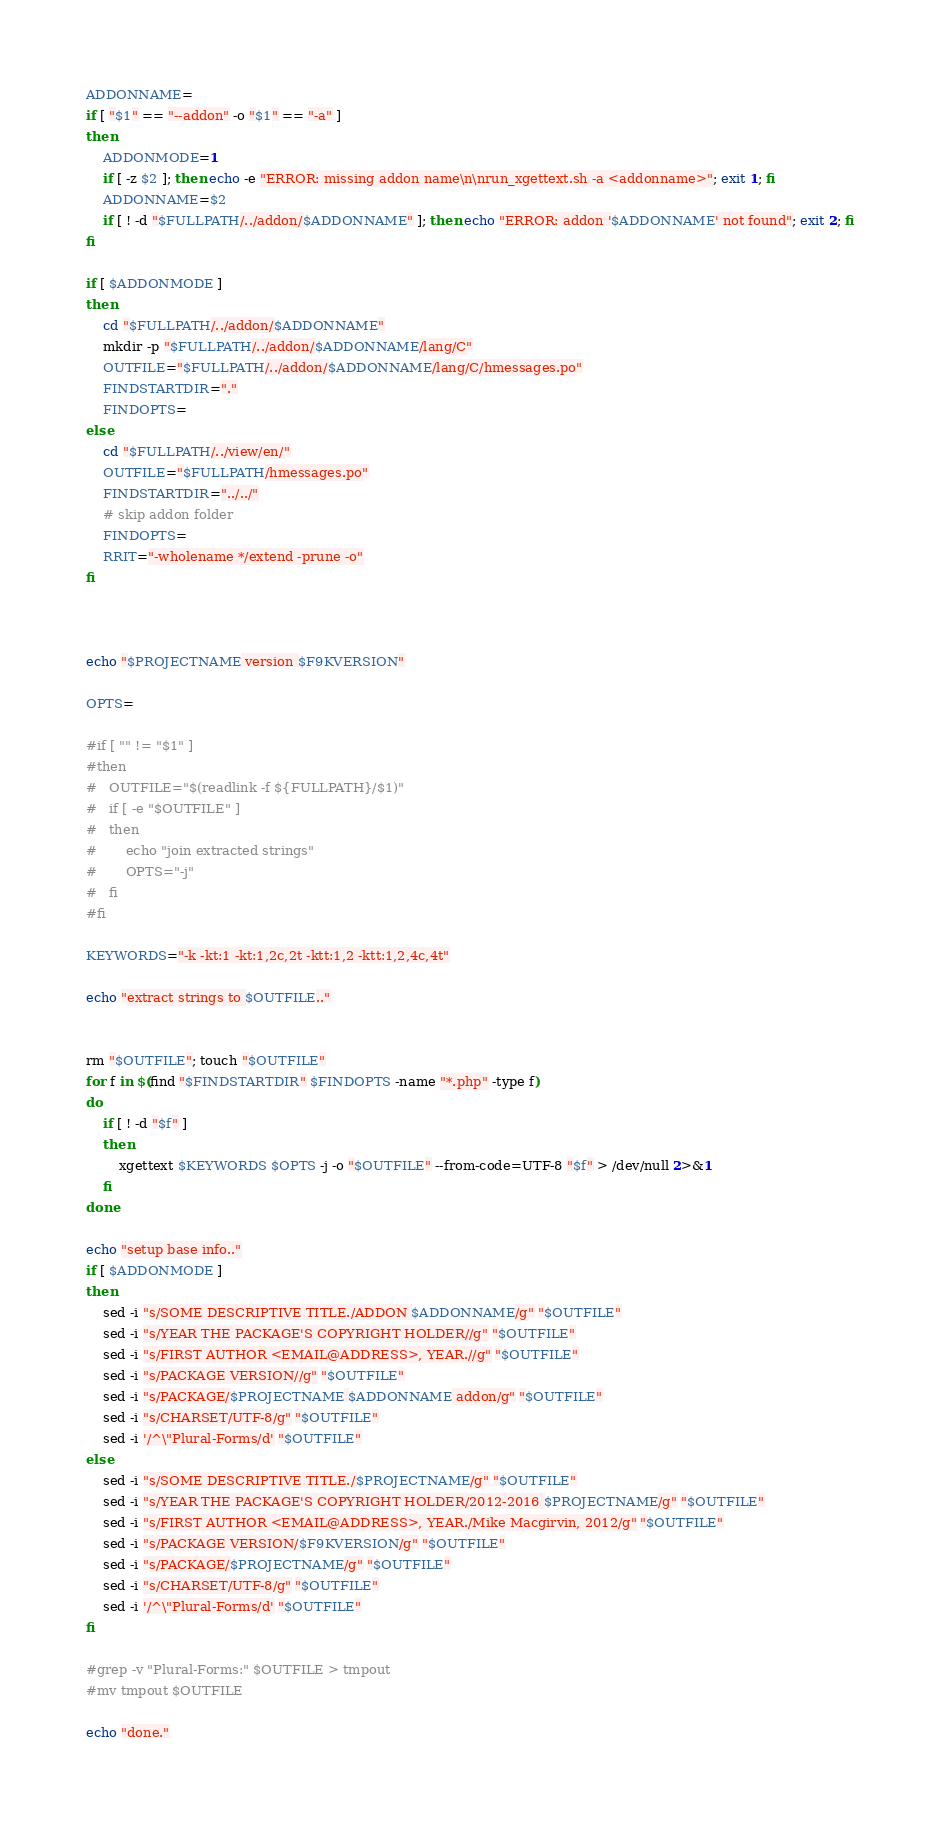Convert code to text. <code><loc_0><loc_0><loc_500><loc_500><_Bash_>ADDONNAME=
if [ "$1" == "--addon" -o "$1" == "-a" ]
then
    ADDONMODE=1
    if [ -z $2 ]; then echo -e "ERROR: missing addon name\n\nrun_xgettext.sh -a <addonname>"; exit 1; fi
    ADDONNAME=$2
    if [ ! -d "$FULLPATH/../addon/$ADDONNAME" ]; then echo "ERROR: addon '$ADDONNAME' not found"; exit 2; fi
fi

if [ $ADDONMODE ]
then
    cd "$FULLPATH/../addon/$ADDONNAME"
    mkdir -p "$FULLPATH/../addon/$ADDONNAME/lang/C"
    OUTFILE="$FULLPATH/../addon/$ADDONNAME/lang/C/hmessages.po"
    FINDSTARTDIR="."
    FINDOPTS=
else
    cd "$FULLPATH/../view/en/"
    OUTFILE="$FULLPATH/hmessages.po"
    FINDSTARTDIR="../../"
    # skip addon folder                                                                                         
    FINDOPTS=
	RRIT="-wholename */extend -prune -o"
fi



echo "$PROJECTNAME version $F9KVERSION"

OPTS=

#if [ "" != "$1" ]
#then
#	OUTFILE="$(readlink -f ${FULLPATH}/$1)"
#	if [ -e "$OUTFILE" ]
#	then
#		echo "join extracted strings"
#		OPTS="-j"
#	fi
#fi

KEYWORDS="-k -kt:1 -kt:1,2c,2t -ktt:1,2 -ktt:1,2,4c,4t"

echo "extract strings to $OUTFILE.."


rm "$OUTFILE"; touch "$OUTFILE"
for f in $(find "$FINDSTARTDIR" $FINDOPTS -name "*.php" -type f)
do
    if [ ! -d "$f" ]
    then
        xgettext $KEYWORDS $OPTS -j -o "$OUTFILE" --from-code=UTF-8 "$f" > /dev/null 2>&1
    fi
done

echo "setup base info.."
if [ $ADDONMODE ]
then
    sed -i "s/SOME DESCRIPTIVE TITLE./ADDON $ADDONNAME/g" "$OUTFILE"
    sed -i "s/YEAR THE PACKAGE'S COPYRIGHT HOLDER//g" "$OUTFILE"
    sed -i "s/FIRST AUTHOR <EMAIL@ADDRESS>, YEAR.//g" "$OUTFILE"
    sed -i "s/PACKAGE VERSION//g" "$OUTFILE"
    sed -i "s/PACKAGE/$PROJECTNAME $ADDONNAME addon/g" "$OUTFILE"
    sed -i "s/CHARSET/UTF-8/g" "$OUTFILE"
	sed -i '/^\"Plural-Forms/d' "$OUTFILE"
else
    sed -i "s/SOME DESCRIPTIVE TITLE./$PROJECTNAME/g" "$OUTFILE"
    sed -i "s/YEAR THE PACKAGE'S COPYRIGHT HOLDER/2012-2016 $PROJECTNAME/g" "$OUTFILE"
    sed -i "s/FIRST AUTHOR <EMAIL@ADDRESS>, YEAR./Mike Macgirvin, 2012/g" "$OUTFILE"
    sed -i "s/PACKAGE VERSION/$F9KVERSION/g" "$OUTFILE"
    sed -i "s/PACKAGE/$PROJECTNAME/g" "$OUTFILE"
    sed -i "s/CHARSET/UTF-8/g" "$OUTFILE"
	sed -i '/^\"Plural-Forms/d' "$OUTFILE"
fi

#grep -v "Plural-Forms:" $OUTFILE > tmpout
#mv tmpout $OUTFILE

echo "done."
</code> 